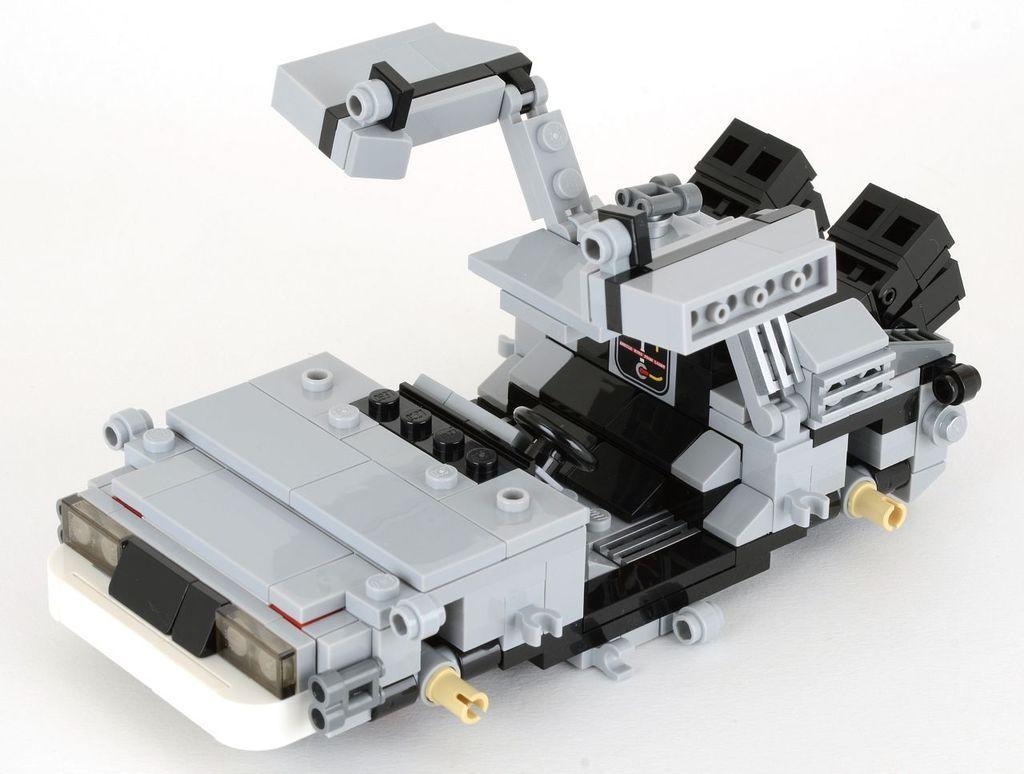Please provide a concise description of this image. In this image I can see a silver and black colour thing on the white colour surface. 